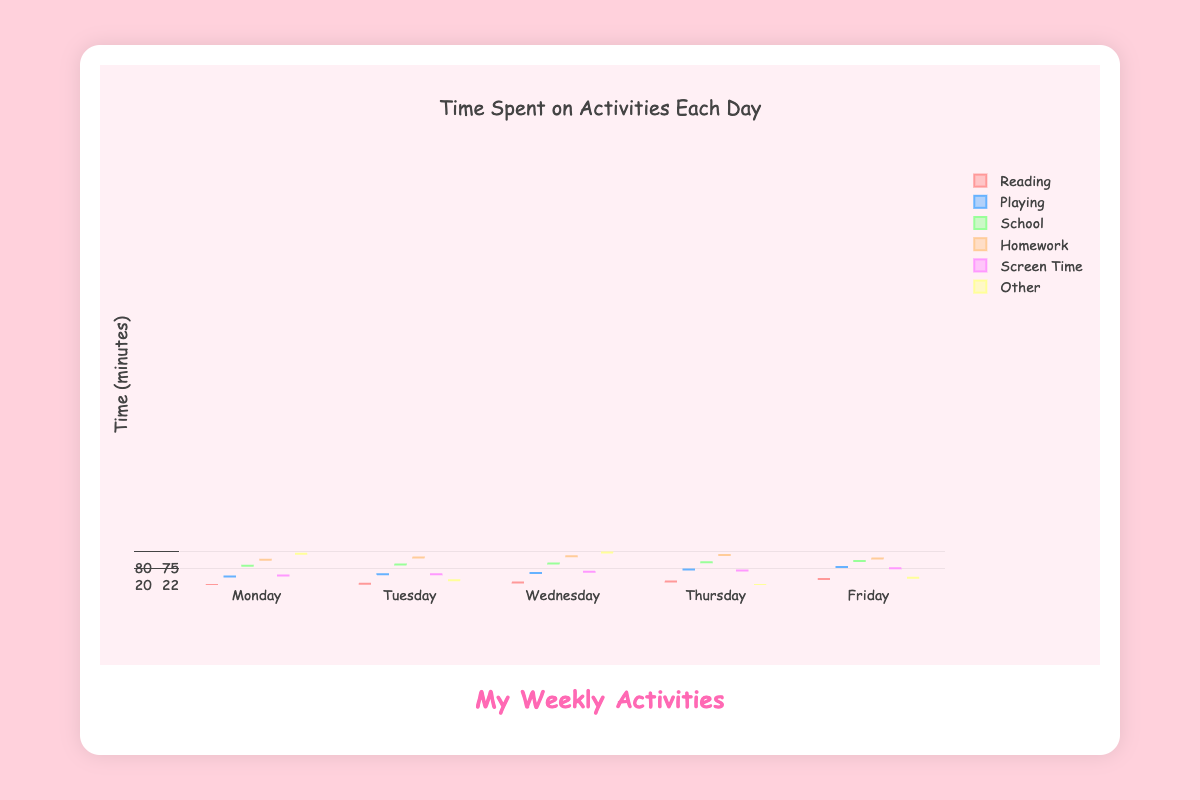What's the title of the figure? The title can be found at the top of the figure in large text.
Answer: "Time Spent on Activities Each Day" How long do kids typically spend at school on Monday? To find this, look at the box plot for "School" on Monday. The box plot shows the spread of the data.
Answer: Around 300 minutes (range: 290 to 310) Which activity has the widest range for Friday? Compare the range (difference between the maximum and minimum values) of each box plot on Friday.
Answer: Playing (range: 60 to 80) Is the median time spent on homework higher on Wednesday or Friday? Look at the median line within the box plots for "Homework" on Wednesday and Friday.
Answer: Wednesday On which day is the time spent playing the most variable? Variability can be seen by comparing the interquartile ranges (IQR) of "Playing" across all days.
Answer: Saturday Which day has less variation in reading time, Tuesday or Thursday? Compare the lengths of the boxes, which represent the interquartile ranges (IQR), for "Reading" on Tuesday and Thursday.
Answer: Thursday What is the most common range of screen time on Sunday? Observe the box plot for "Screen Time" on Sunday and identify the spread of the middle 50% of data points.
Answer: 60 to 75 minutes How does the median school time on Monday compare to Tuesday? Look at the median lines inside the box plots for "School" on Monday and Tuesday and compare their positions.
Answer: Slightly higher on Tuesday What can you say about the outliers for the activity 'Other' during the week? Check for any points outside the whiskers in the box plots for "Other" on each day.
Answer: Outliers are sparse, typically within the whisker range How much more screen time is typically spent on Saturday compared to Wednesday? Compare the median (middle line of the box) of "Screen Time" for Saturday and Wednesday, then subtract to find the difference.
Answer: 10 minutes more (75 vs. 65) 